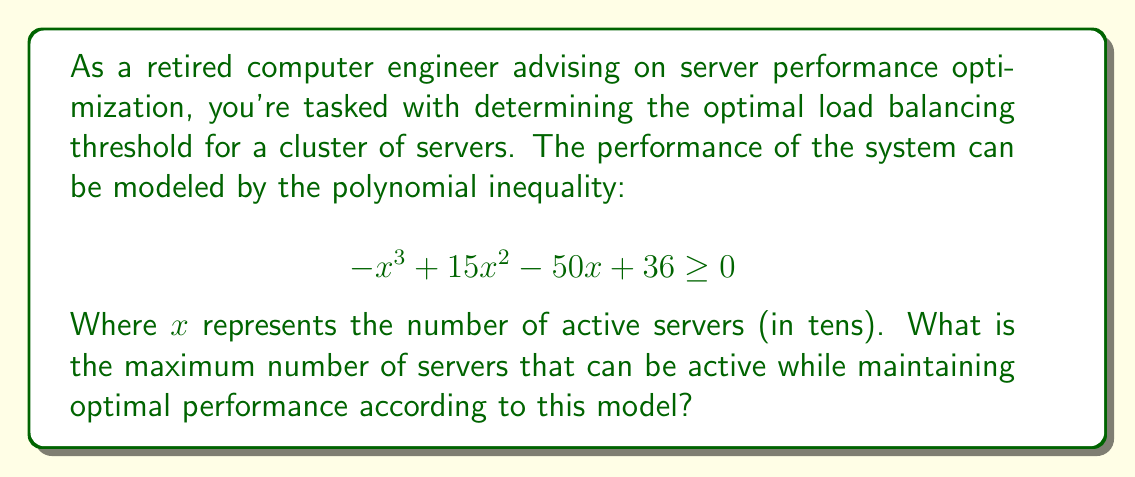Give your solution to this math problem. To solve this problem, we need to find the largest value of $x$ that satisfies the given inequality. Let's approach this step-by-step:

1) First, we need to find the roots of the equation:

   $$ -x^3 + 15x^2 - 50x + 36 = 0 $$

2) This is a cubic equation. It can be factored as:

   $$ -(x - 1)(x - 4)(x - 9) = 0 $$

3) The roots of this equation are $x = 1$, $x = 4$, and $x = 9$.

4) Now, let's consider the inequality:

   $$ -x^3 + 15x^2 - 50x + 36 \geq 0 $$

5) The inequality will be satisfied when $x$ is between the first two roots (1 and 4) or greater than or equal to the largest root (9).

6) Since we're looking for the maximum number of servers, we're interested in values of $x$ greater than or equal to 9.

7) Remember that $x$ represents the number of servers in tens. So $x = 9$ actually represents 90 servers.

8) Since we need a whole number of servers, and we're looking for the maximum, we should round down to ensure we don't exceed the threshold.

Therefore, the maximum number of servers that can be active while maintaining optimal performance is 90.
Answer: 90 servers 